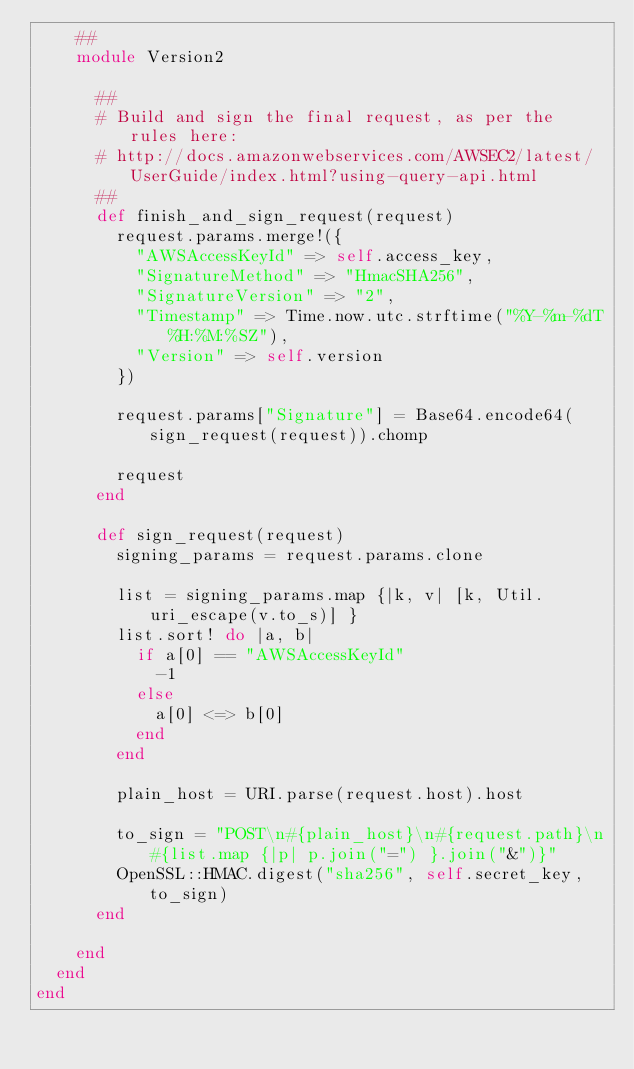Convert code to text. <code><loc_0><loc_0><loc_500><loc_500><_Ruby_>    ##
    module Version2

      ##
      # Build and sign the final request, as per the rules here:
      # http://docs.amazonwebservices.com/AWSEC2/latest/UserGuide/index.html?using-query-api.html
      ##
      def finish_and_sign_request(request)
        request.params.merge!({
          "AWSAccessKeyId" => self.access_key,
          "SignatureMethod" => "HmacSHA256",
          "SignatureVersion" => "2",
          "Timestamp" => Time.now.utc.strftime("%Y-%m-%dT%H:%M:%SZ"),
          "Version" => self.version
        })

        request.params["Signature"] = Base64.encode64(sign_request(request)).chomp

        request
      end

      def sign_request(request)
        signing_params = request.params.clone

        list = signing_params.map {|k, v| [k, Util.uri_escape(v.to_s)] }
        list.sort! do |a, b|
          if a[0] == "AWSAccessKeyId"
            -1
          else
            a[0] <=> b[0]
          end
        end

        plain_host = URI.parse(request.host).host

        to_sign = "POST\n#{plain_host}\n#{request.path}\n#{list.map {|p| p.join("=") }.join("&")}"
        OpenSSL::HMAC.digest("sha256", self.secret_key, to_sign)
      end

    end
  end
end
</code> 